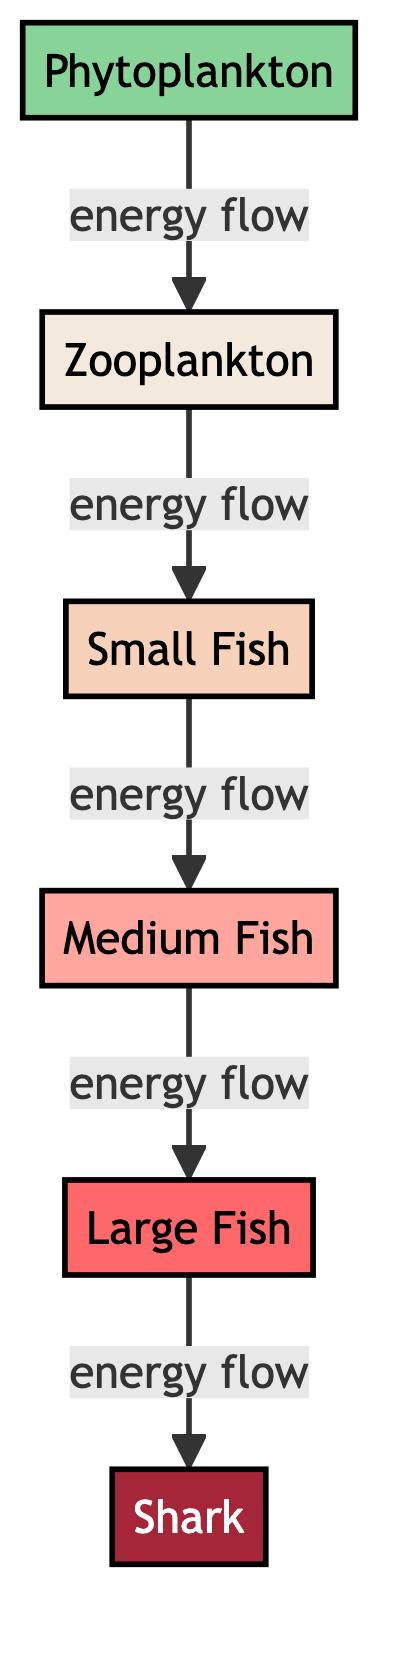What is the first node in the food chain? The first node in the food chain is the producer, which in this case is phytoplankton.
Answer: Phytoplankton How many total nodes are in the diagram? The diagram contains six nodes: phytoplankton, zooplankton, small fish, medium fish, large fish, and shark.
Answer: 6 What is the role of zooplankton in the food chain? Zooplankton is the primary consumer in the food chain, consuming energy from phytoplankton.
Answer: Primary consumer Which consumer level comes after medium fish? The consumer level that comes after medium fish is large fish, indicating the energy flow continues in the chain.
Answer: Large fish Which organism is at the top of the food chain? The organism at the top of the food chain, symbolizing the apex predator, is the shark, which has no natural predators in this context.
Answer: Shark How many energy flows are present in the diagram? The number of energy flows present in the diagram is five, demonstrated by the directional arrows connecting the nodes.
Answer: 5 If zooplankton is removed, how many consumer levels will remain? If zooplankton is removed, small fish, medium fish, large fish, and shark will remain, resulting in four consumer levels, since all subsequent levels rely on it as a primary consumer.
Answer: 4 What type of consumer is large fish? Large fish is classified as a quaternary consumer in this food chain diagram, reflecting its position in the sequence of energy transfer.
Answer: Quaternary consumer What type of relationship exists between phytoplankton and zooplankton? The relationship between phytoplankton and zooplankton is one of energy flow, with phytoplankton providing energy to zooplankton when consumed.
Answer: Energy flow 